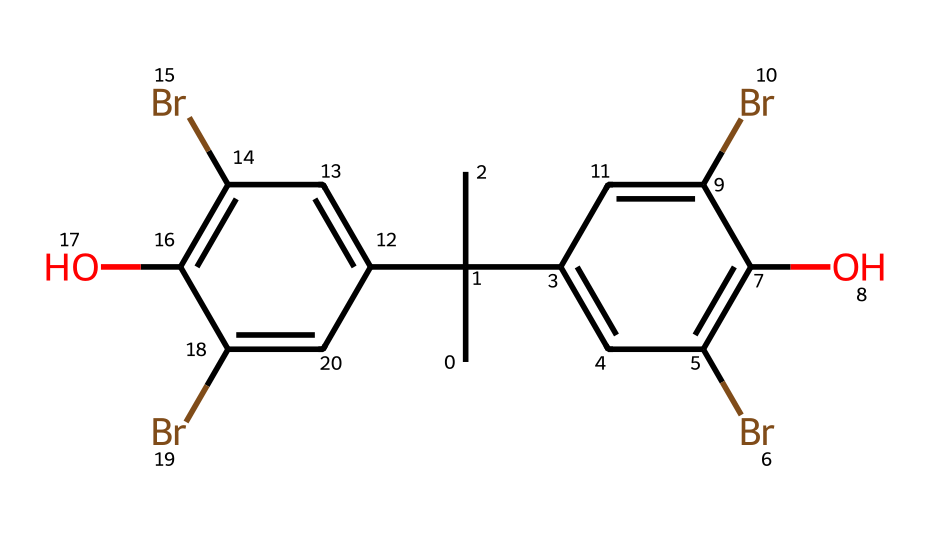How many bromine atoms are in the structure? The SMILES representation shows the presence of the 'Br' notation, which indicates bromine atoms. In the provided SMILES, 'Br' appears four times, indicating there are four bromine atoms present.
Answer: four What functional groups are present in this chemical? The 'O' in the SMILES indicates the presence of hydroxyl (-OH) functional groups, and the multiple benzene rings indicate aromatic characteristics. Overall, there are hydroxyl groups and aromatic rings present.
Answer: hydroxyl, aromatic What type of chemical is this, based on halogen content? The presence of bromine signifies that this chemical is a brominated compound. Brominated compounds are recognized for their flame retardant properties, emphasizing their utility in industry applications such as upholstery.
Answer: brominated How many aromatic rings are there in the structure? By analyzing the chemical structure, we note that there are two distinct sections with 'c1cc' patterns, indicating the presence of benzene rings. Each of these indicates a separate aromatic ring. In total, there are two aromatic rings in this structure.
Answer: two What is the primary purpose of bromine-based chemicals like this one? Bromine-based flame retardants are primarily used to reduce flammability and are added to materials such as upholstery to prevent fire hazards. This application is valuable in settings such as restaurants, where fire safety is crucial.
Answer: fire retardant What molecular features contribute to the flame retardant properties in this chemical? The presence of multiple bromine atoms contributes to enhanced flame retardant properties, as brominated compounds tend to interrupt reactions that sustain combustion. Additionally, the aromatic structure can stabilize the molecule and support its function as a flame retardant.
Answer: bromine, aromatic structure 